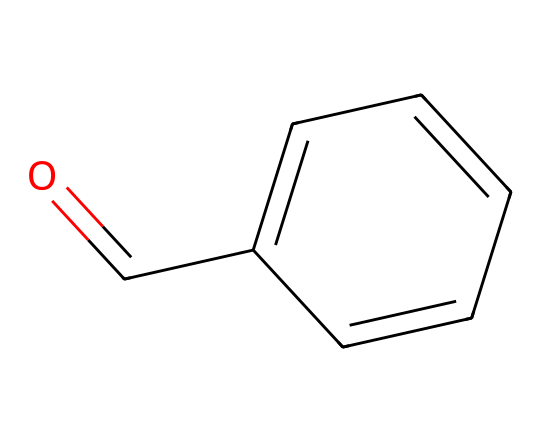What is the name of this chemical? The SMILES representation indicates the presence of a carbonyl group (O=C) attached to a benzene ring (c1ccccc1), which is characteristic of benzaldehyde.
Answer: benzaldehyde How many carbon atoms are in benzaldehyde? By analyzing the SMILES, the carbonyl carbon counts as one carbon, and there are six carbon atoms in the benzene ring, totaling seven carbon atoms.
Answer: seven What type of functional group is present in benzaldehyde? The presence of the carbonyl group (C=O) linked to a hydrogen atom directly signifies that this is an aldehyde functional group.
Answer: aldehyde What is the molecular formula of benzaldehyde? The chemical consists of seven carbon atoms, six hydrogen atoms, and one oxygen atom, which leads to the molecular formula C7H6O.
Answer: C7H6O How many hydrogen atoms are present in the structure of benzaldehyde? The benzene ring has five hydrogen atoms, plus one hydrogen atom connected to the carbonyl carbon, resulting in a total of six hydrogen atoms.
Answer: six What is the hybridization of the carbon in the carbonyl group of benzaldehyde? The carbon in the carbonyl group is sp2 hybridized due to its double bond with oxygen and single bond with both the adjacent carbon in the benzene ring and a hydrogen atom.
Answer: sp2 What property makes benzaldehyde have an almond scent? The aromatic ring and the specific arrangement of the functional groups contribute to its unique aroma, characterizing it as having an almond scent.
Answer: almond scent 